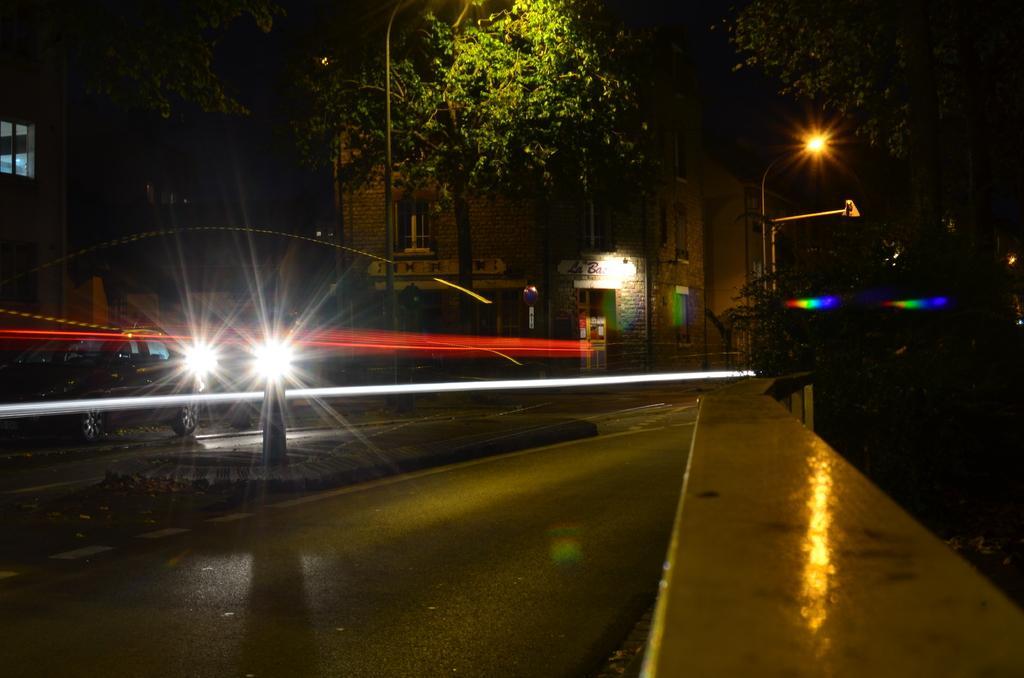Please provide a concise description of this image. In this image we can see vehicle, light poles, trees and we can also see the corners of the image are dark. 